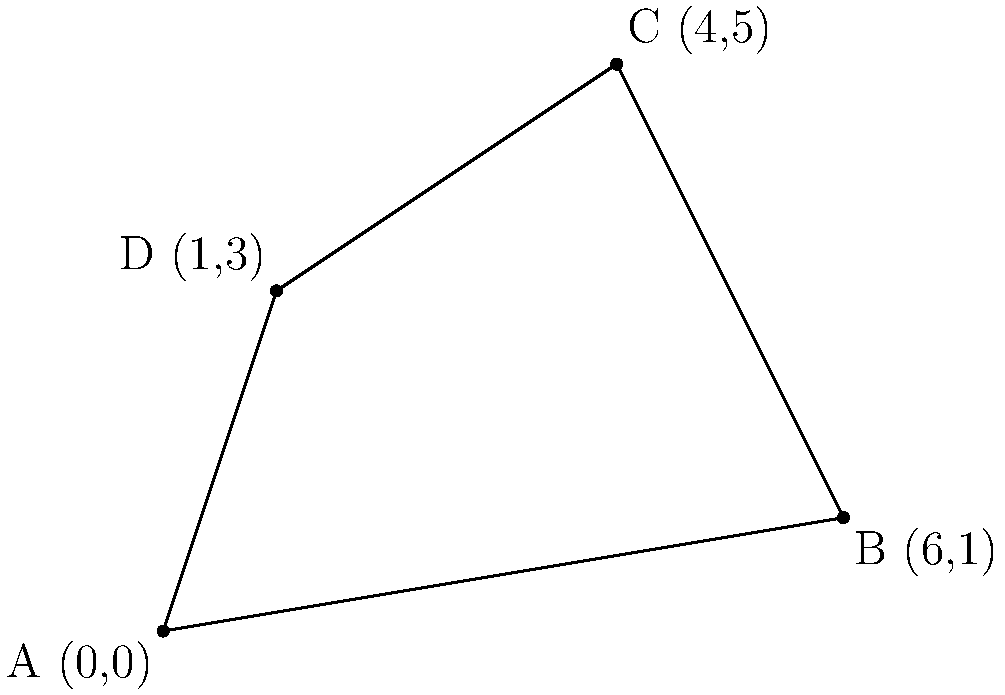Four important archaeological sites have been discovered in an ancient city. Their locations on a coordinate system are as follows: Site A (0,0), Site B (6,1), Site C (4,5), and Site D (1,3). These sites form a quadrilateral when connected. Calculate the area of this quadrilateral using coordinate geometry methods. To find the area of the quadrilateral, we can use the Shoelace formula (also known as the surveyor's formula). This method is particularly useful when we have the coordinates of all vertices.

Step 1: Arrange the coordinates in order (either clockwise or counterclockwise).
A(0,0), B(6,1), C(4,5), D(1,3)

Step 2: Apply the Shoelace formula:
Area = $\frac{1}{2}|[(x_1y_2 + x_2y_3 + x_3y_4 + x_4y_1) - (y_1x_2 + y_2x_3 + y_3x_4 + y_4x_1)]|$

Where $(x_1,y_1)$, $(x_2,y_2)$, $(x_3,y_3)$, and $(x_4,y_4)$ are the coordinates of points A, B, C, and D respectively.

Step 3: Substitute the values:
Area = $\frac{1}{2}|[(0 \cdot 1 + 6 \cdot 5 + 4 \cdot 3 + 1 \cdot 0) - (0 \cdot 6 + 1 \cdot 4 + 5 \cdot 1 + 3 \cdot 0)]|$

Step 4: Calculate:
Area = $\frac{1}{2}|[(0 + 30 + 12 + 0) - (0 + 4 + 5 + 0)]|$
     = $\frac{1}{2}|[42 - 9]|$
     = $\frac{1}{2}|33|$
     = $\frac{33}{2}$
     = 16.5

Therefore, the area of the quadrilateral is 16.5 square units.
Answer: 16.5 square units 